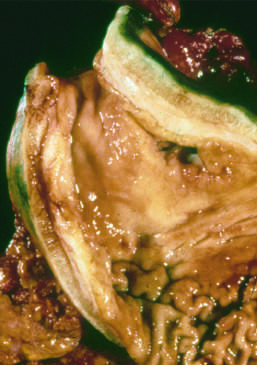s an arteriole markedly thickened?
Answer the question using a single word or phrase. No 